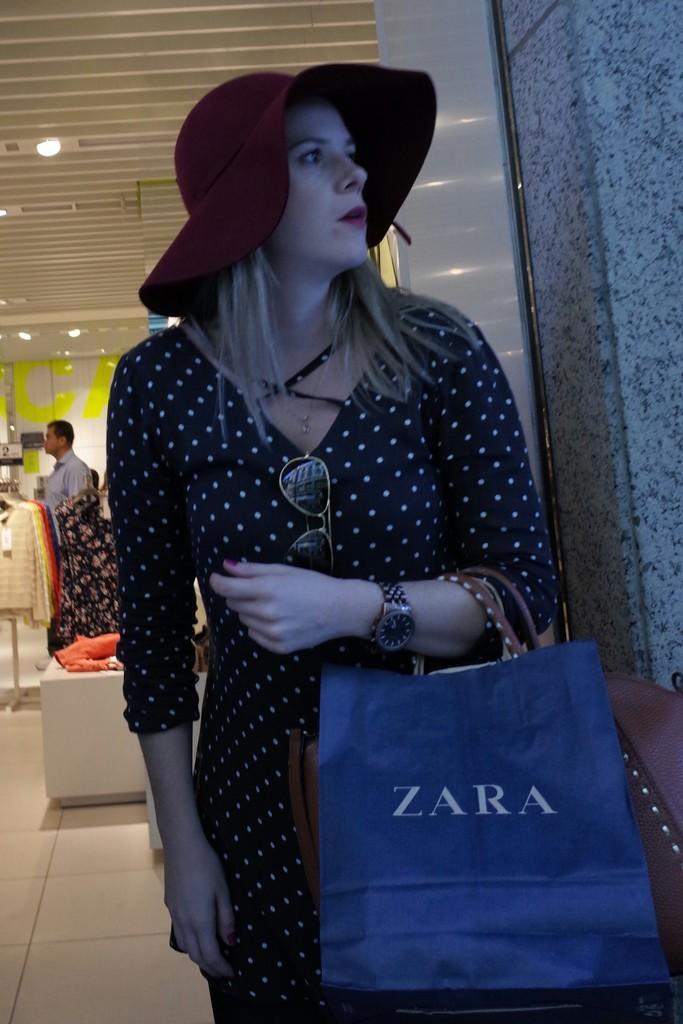How would you summarize this image in a sentence or two? In this image I can see a person standing and holding a bag. Back I can see few tops,lights and one person is standing. 